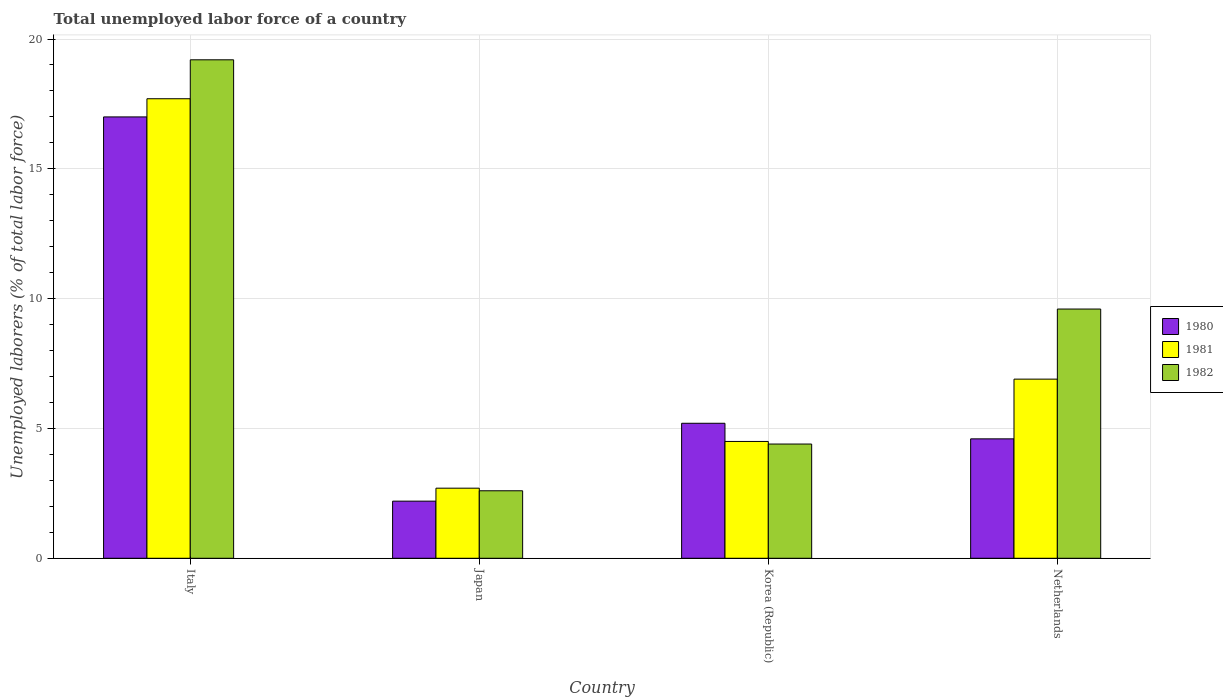Are the number of bars per tick equal to the number of legend labels?
Your answer should be compact. Yes. Are the number of bars on each tick of the X-axis equal?
Provide a succinct answer. Yes. How many bars are there on the 3rd tick from the right?
Provide a short and direct response. 3. In how many cases, is the number of bars for a given country not equal to the number of legend labels?
Ensure brevity in your answer.  0. Across all countries, what is the maximum total unemployed labor force in 1981?
Your response must be concise. 17.7. Across all countries, what is the minimum total unemployed labor force in 1981?
Your answer should be compact. 2.7. In which country was the total unemployed labor force in 1980 maximum?
Your answer should be compact. Italy. In which country was the total unemployed labor force in 1982 minimum?
Ensure brevity in your answer.  Japan. What is the total total unemployed labor force in 1981 in the graph?
Provide a short and direct response. 31.8. What is the difference between the total unemployed labor force in 1980 in Japan and that in Korea (Republic)?
Make the answer very short. -3. What is the difference between the total unemployed labor force in 1982 in Japan and the total unemployed labor force in 1980 in Korea (Republic)?
Offer a very short reply. -2.6. What is the average total unemployed labor force in 1981 per country?
Offer a terse response. 7.95. What is the difference between the total unemployed labor force of/in 1982 and total unemployed labor force of/in 1981 in Italy?
Give a very brief answer. 1.5. In how many countries, is the total unemployed labor force in 1981 greater than 8 %?
Provide a succinct answer. 1. What is the ratio of the total unemployed labor force in 1980 in Italy to that in Japan?
Your answer should be very brief. 7.73. Is the total unemployed labor force in 1980 in Italy less than that in Korea (Republic)?
Offer a very short reply. No. What is the difference between the highest and the second highest total unemployed labor force in 1981?
Your answer should be compact. 13.2. What is the difference between the highest and the lowest total unemployed labor force in 1980?
Make the answer very short. 14.8. Is the sum of the total unemployed labor force in 1982 in Italy and Korea (Republic) greater than the maximum total unemployed labor force in 1981 across all countries?
Your answer should be very brief. Yes. What does the 3rd bar from the left in Korea (Republic) represents?
Provide a short and direct response. 1982. Is it the case that in every country, the sum of the total unemployed labor force in 1982 and total unemployed labor force in 1980 is greater than the total unemployed labor force in 1981?
Your answer should be very brief. Yes. How many countries are there in the graph?
Provide a short and direct response. 4. What is the difference between two consecutive major ticks on the Y-axis?
Provide a short and direct response. 5. Are the values on the major ticks of Y-axis written in scientific E-notation?
Your response must be concise. No. Where does the legend appear in the graph?
Provide a short and direct response. Center right. What is the title of the graph?
Provide a succinct answer. Total unemployed labor force of a country. What is the label or title of the Y-axis?
Your answer should be compact. Unemployed laborers (% of total labor force). What is the Unemployed laborers (% of total labor force) in 1980 in Italy?
Your answer should be compact. 17. What is the Unemployed laborers (% of total labor force) in 1981 in Italy?
Offer a very short reply. 17.7. What is the Unemployed laborers (% of total labor force) in 1982 in Italy?
Your answer should be compact. 19.2. What is the Unemployed laborers (% of total labor force) of 1980 in Japan?
Keep it short and to the point. 2.2. What is the Unemployed laborers (% of total labor force) of 1981 in Japan?
Give a very brief answer. 2.7. What is the Unemployed laborers (% of total labor force) in 1982 in Japan?
Your answer should be compact. 2.6. What is the Unemployed laborers (% of total labor force) of 1980 in Korea (Republic)?
Give a very brief answer. 5.2. What is the Unemployed laborers (% of total labor force) in 1981 in Korea (Republic)?
Make the answer very short. 4.5. What is the Unemployed laborers (% of total labor force) in 1982 in Korea (Republic)?
Your response must be concise. 4.4. What is the Unemployed laborers (% of total labor force) of 1980 in Netherlands?
Make the answer very short. 4.6. What is the Unemployed laborers (% of total labor force) of 1981 in Netherlands?
Your response must be concise. 6.9. What is the Unemployed laborers (% of total labor force) in 1982 in Netherlands?
Keep it short and to the point. 9.6. Across all countries, what is the maximum Unemployed laborers (% of total labor force) in 1981?
Give a very brief answer. 17.7. Across all countries, what is the maximum Unemployed laborers (% of total labor force) of 1982?
Give a very brief answer. 19.2. Across all countries, what is the minimum Unemployed laborers (% of total labor force) in 1980?
Give a very brief answer. 2.2. Across all countries, what is the minimum Unemployed laborers (% of total labor force) of 1981?
Offer a terse response. 2.7. Across all countries, what is the minimum Unemployed laborers (% of total labor force) in 1982?
Provide a short and direct response. 2.6. What is the total Unemployed laborers (% of total labor force) of 1980 in the graph?
Ensure brevity in your answer.  29. What is the total Unemployed laborers (% of total labor force) in 1981 in the graph?
Offer a very short reply. 31.8. What is the total Unemployed laborers (% of total labor force) of 1982 in the graph?
Provide a short and direct response. 35.8. What is the difference between the Unemployed laborers (% of total labor force) in 1982 in Italy and that in Japan?
Provide a succinct answer. 16.6. What is the difference between the Unemployed laborers (% of total labor force) of 1980 in Italy and that in Korea (Republic)?
Provide a succinct answer. 11.8. What is the difference between the Unemployed laborers (% of total labor force) in 1982 in Italy and that in Korea (Republic)?
Keep it short and to the point. 14.8. What is the difference between the Unemployed laborers (% of total labor force) in 1980 in Italy and that in Netherlands?
Keep it short and to the point. 12.4. What is the difference between the Unemployed laborers (% of total labor force) of 1982 in Italy and that in Netherlands?
Provide a succinct answer. 9.6. What is the difference between the Unemployed laborers (% of total labor force) in 1982 in Japan and that in Korea (Republic)?
Make the answer very short. -1.8. What is the difference between the Unemployed laborers (% of total labor force) in 1980 in Japan and that in Netherlands?
Make the answer very short. -2.4. What is the difference between the Unemployed laborers (% of total labor force) in 1980 in Korea (Republic) and that in Netherlands?
Your answer should be very brief. 0.6. What is the difference between the Unemployed laborers (% of total labor force) in 1981 in Korea (Republic) and that in Netherlands?
Offer a terse response. -2.4. What is the difference between the Unemployed laborers (% of total labor force) in 1980 in Italy and the Unemployed laborers (% of total labor force) in 1981 in Japan?
Your response must be concise. 14.3. What is the difference between the Unemployed laborers (% of total labor force) of 1980 in Italy and the Unemployed laborers (% of total labor force) of 1982 in Japan?
Your response must be concise. 14.4. What is the difference between the Unemployed laborers (% of total labor force) in 1981 in Italy and the Unemployed laborers (% of total labor force) in 1982 in Japan?
Your response must be concise. 15.1. What is the difference between the Unemployed laborers (% of total labor force) in 1980 in Italy and the Unemployed laborers (% of total labor force) in 1981 in Korea (Republic)?
Ensure brevity in your answer.  12.5. What is the difference between the Unemployed laborers (% of total labor force) of 1980 in Italy and the Unemployed laborers (% of total labor force) of 1982 in Korea (Republic)?
Your response must be concise. 12.6. What is the difference between the Unemployed laborers (% of total labor force) of 1980 in Italy and the Unemployed laborers (% of total labor force) of 1981 in Netherlands?
Offer a very short reply. 10.1. What is the difference between the Unemployed laborers (% of total labor force) in 1980 in Italy and the Unemployed laborers (% of total labor force) in 1982 in Netherlands?
Offer a very short reply. 7.4. What is the difference between the Unemployed laborers (% of total labor force) of 1980 in Japan and the Unemployed laborers (% of total labor force) of 1981 in Netherlands?
Offer a very short reply. -4.7. What is the difference between the Unemployed laborers (% of total labor force) in 1980 in Japan and the Unemployed laborers (% of total labor force) in 1982 in Netherlands?
Make the answer very short. -7.4. What is the difference between the Unemployed laborers (% of total labor force) of 1981 in Japan and the Unemployed laborers (% of total labor force) of 1982 in Netherlands?
Give a very brief answer. -6.9. What is the difference between the Unemployed laborers (% of total labor force) in 1980 in Korea (Republic) and the Unemployed laborers (% of total labor force) in 1981 in Netherlands?
Provide a succinct answer. -1.7. What is the difference between the Unemployed laborers (% of total labor force) of 1980 in Korea (Republic) and the Unemployed laborers (% of total labor force) of 1982 in Netherlands?
Provide a short and direct response. -4.4. What is the average Unemployed laborers (% of total labor force) in 1980 per country?
Keep it short and to the point. 7.25. What is the average Unemployed laborers (% of total labor force) in 1981 per country?
Keep it short and to the point. 7.95. What is the average Unemployed laborers (% of total labor force) in 1982 per country?
Offer a very short reply. 8.95. What is the difference between the Unemployed laborers (% of total labor force) of 1981 and Unemployed laborers (% of total labor force) of 1982 in Italy?
Provide a succinct answer. -1.5. What is the difference between the Unemployed laborers (% of total labor force) of 1980 and Unemployed laborers (% of total labor force) of 1981 in Japan?
Keep it short and to the point. -0.5. What is the difference between the Unemployed laborers (% of total labor force) in 1980 and Unemployed laborers (% of total labor force) in 1982 in Japan?
Your answer should be compact. -0.4. What is the difference between the Unemployed laborers (% of total labor force) of 1981 and Unemployed laborers (% of total labor force) of 1982 in Japan?
Offer a terse response. 0.1. What is the difference between the Unemployed laborers (% of total labor force) of 1981 and Unemployed laborers (% of total labor force) of 1982 in Korea (Republic)?
Provide a short and direct response. 0.1. What is the difference between the Unemployed laborers (% of total labor force) of 1980 and Unemployed laborers (% of total labor force) of 1982 in Netherlands?
Give a very brief answer. -5. What is the ratio of the Unemployed laborers (% of total labor force) of 1980 in Italy to that in Japan?
Provide a succinct answer. 7.73. What is the ratio of the Unemployed laborers (% of total labor force) in 1981 in Italy to that in Japan?
Your answer should be very brief. 6.56. What is the ratio of the Unemployed laborers (% of total labor force) in 1982 in Italy to that in Japan?
Offer a very short reply. 7.38. What is the ratio of the Unemployed laborers (% of total labor force) of 1980 in Italy to that in Korea (Republic)?
Keep it short and to the point. 3.27. What is the ratio of the Unemployed laborers (% of total labor force) of 1981 in Italy to that in Korea (Republic)?
Keep it short and to the point. 3.93. What is the ratio of the Unemployed laborers (% of total labor force) of 1982 in Italy to that in Korea (Republic)?
Keep it short and to the point. 4.36. What is the ratio of the Unemployed laborers (% of total labor force) in 1980 in Italy to that in Netherlands?
Make the answer very short. 3.7. What is the ratio of the Unemployed laborers (% of total labor force) of 1981 in Italy to that in Netherlands?
Provide a succinct answer. 2.57. What is the ratio of the Unemployed laborers (% of total labor force) in 1982 in Italy to that in Netherlands?
Provide a succinct answer. 2. What is the ratio of the Unemployed laborers (% of total labor force) of 1980 in Japan to that in Korea (Republic)?
Your response must be concise. 0.42. What is the ratio of the Unemployed laborers (% of total labor force) of 1981 in Japan to that in Korea (Republic)?
Make the answer very short. 0.6. What is the ratio of the Unemployed laborers (% of total labor force) in 1982 in Japan to that in Korea (Republic)?
Your answer should be very brief. 0.59. What is the ratio of the Unemployed laborers (% of total labor force) of 1980 in Japan to that in Netherlands?
Your response must be concise. 0.48. What is the ratio of the Unemployed laborers (% of total labor force) of 1981 in Japan to that in Netherlands?
Your answer should be very brief. 0.39. What is the ratio of the Unemployed laborers (% of total labor force) of 1982 in Japan to that in Netherlands?
Your answer should be very brief. 0.27. What is the ratio of the Unemployed laborers (% of total labor force) in 1980 in Korea (Republic) to that in Netherlands?
Give a very brief answer. 1.13. What is the ratio of the Unemployed laborers (% of total labor force) of 1981 in Korea (Republic) to that in Netherlands?
Provide a succinct answer. 0.65. What is the ratio of the Unemployed laborers (% of total labor force) in 1982 in Korea (Republic) to that in Netherlands?
Keep it short and to the point. 0.46. 